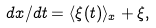<formula> <loc_0><loc_0><loc_500><loc_500>d x / d t = \langle \xi ( t ) \rangle _ { x } + \xi ,</formula> 